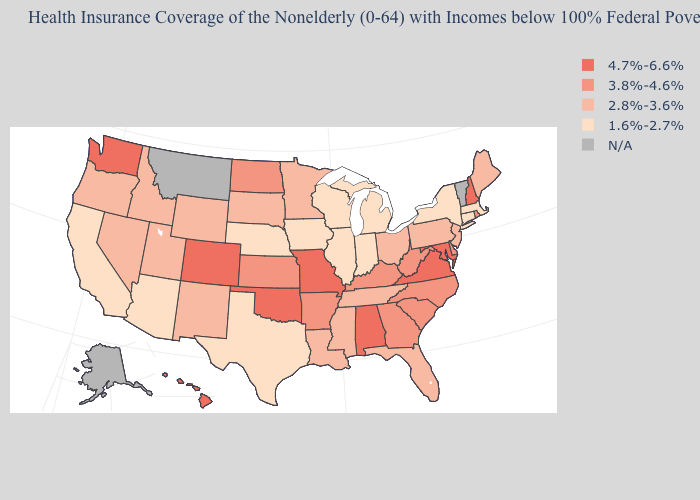What is the highest value in states that border New Hampshire?
Answer briefly. 2.8%-3.6%. What is the value of Rhode Island?
Write a very short answer. 3.8%-4.6%. What is the value of Minnesota?
Quick response, please. 2.8%-3.6%. Name the states that have a value in the range 1.6%-2.7%?
Quick response, please. Arizona, California, Connecticut, Illinois, Indiana, Iowa, Massachusetts, Michigan, Nebraska, New York, Texas, Wisconsin. Does the map have missing data?
Quick response, please. Yes. What is the highest value in the USA?
Write a very short answer. 4.7%-6.6%. What is the value of North Carolina?
Write a very short answer. 3.8%-4.6%. What is the value of Michigan?
Short answer required. 1.6%-2.7%. Does Iowa have the lowest value in the MidWest?
Write a very short answer. Yes. Does Georgia have the highest value in the USA?
Give a very brief answer. No. Which states have the lowest value in the USA?
Quick response, please. Arizona, California, Connecticut, Illinois, Indiana, Iowa, Massachusetts, Michigan, Nebraska, New York, Texas, Wisconsin. Does North Carolina have the lowest value in the USA?
Give a very brief answer. No. Name the states that have a value in the range 2.8%-3.6%?
Answer briefly. Florida, Idaho, Louisiana, Maine, Minnesota, Mississippi, Nevada, New Jersey, New Mexico, Ohio, Oregon, Pennsylvania, South Dakota, Tennessee, Utah, Wyoming. What is the lowest value in the USA?
Concise answer only. 1.6%-2.7%. 